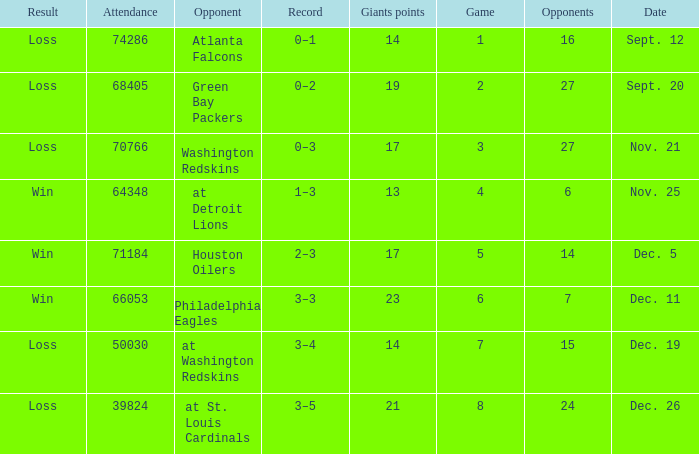What is the record when the opponent is washington redskins? 0–3. Can you give me this table as a dict? {'header': ['Result', 'Attendance', 'Opponent', 'Record', 'Giants points', 'Game', 'Opponents', 'Date'], 'rows': [['Loss', '74286', 'Atlanta Falcons', '0–1', '14', '1', '16', 'Sept. 12'], ['Loss', '68405', 'Green Bay Packers', '0–2', '19', '2', '27', 'Sept. 20'], ['Loss', '70766', 'Washington Redskins', '0–3', '17', '3', '27', 'Nov. 21'], ['Win', '64348', 'at Detroit Lions', '1–3', '13', '4', '6', 'Nov. 25'], ['Win', '71184', 'Houston Oilers', '2–3', '17', '5', '14', 'Dec. 5'], ['Win', '66053', 'Philadelphia Eagles', '3–3', '23', '6', '7', 'Dec. 11'], ['Loss', '50030', 'at Washington Redskins', '3–4', '14', '7', '15', 'Dec. 19'], ['Loss', '39824', 'at St. Louis Cardinals', '3–5', '21', '8', '24', 'Dec. 26']]} 